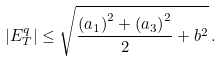<formula> <loc_0><loc_0><loc_500><loc_500>| E _ { T } ^ { q } | \leq \sqrt { \frac { \left ( a _ { 1 } \right ) ^ { 2 } + \left ( a _ { 3 } \right ) ^ { 2 } } { 2 } + b ^ { 2 } } \, .</formula> 